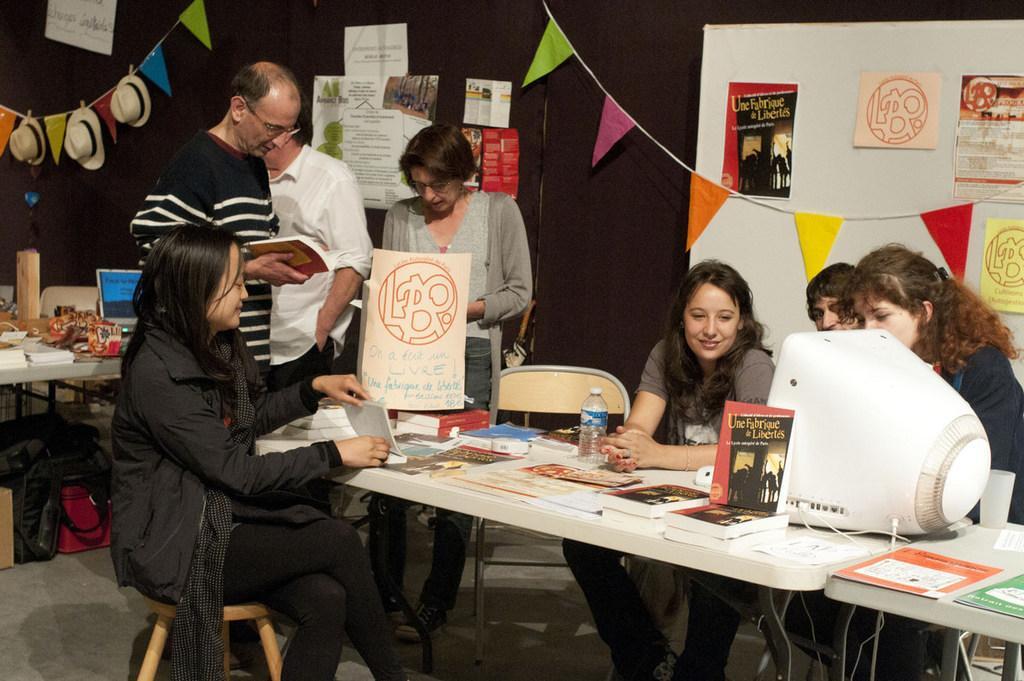In one or two sentences, can you explain what this image depicts? In the picture we can see some people few are sitting and watching monitor and some people are standing and reading books and doing some work and one woman is sitting and seeing the book. In background we can see some decorative items three hats and papers stick on wall and on floor some bags. 